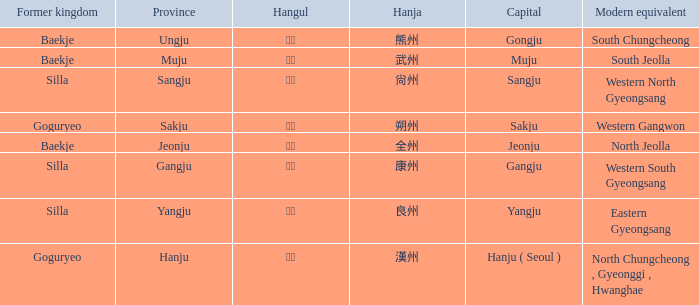Which capital is associated with the hanja 尙州? Sangju. 